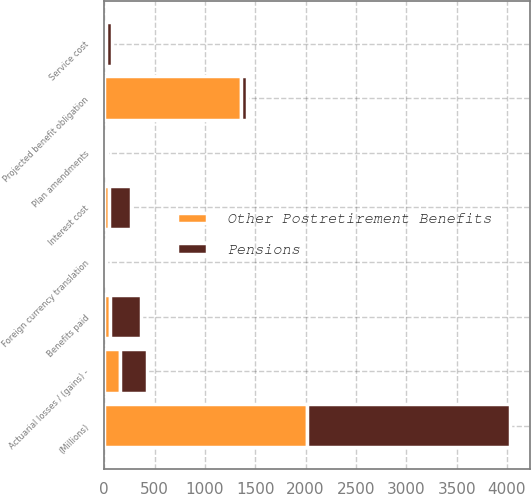Convert chart to OTSL. <chart><loc_0><loc_0><loc_500><loc_500><stacked_bar_chart><ecel><fcel>(Millions)<fcel>Projected benefit obligation<fcel>Service cost<fcel>Interest cost<fcel>Plan amendments<fcel>Actuarial losses / (gains) -<fcel>Benefits paid<fcel>Foreign currency translation<nl><fcel>Pensions<fcel>2013<fcel>60<fcel>57<fcel>218<fcel>25<fcel>267<fcel>304<fcel>12<nl><fcel>Other Postretirement Benefits<fcel>2013<fcel>1362<fcel>20<fcel>49<fcel>8<fcel>160<fcel>60<fcel>8<nl></chart> 